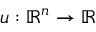Convert formula to latex. <formula><loc_0><loc_0><loc_500><loc_500>u \colon \mathbb { R } ^ { n } \to \mathbb { R }</formula> 